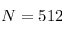<formula> <loc_0><loc_0><loc_500><loc_500>N = 5 1 2</formula> 